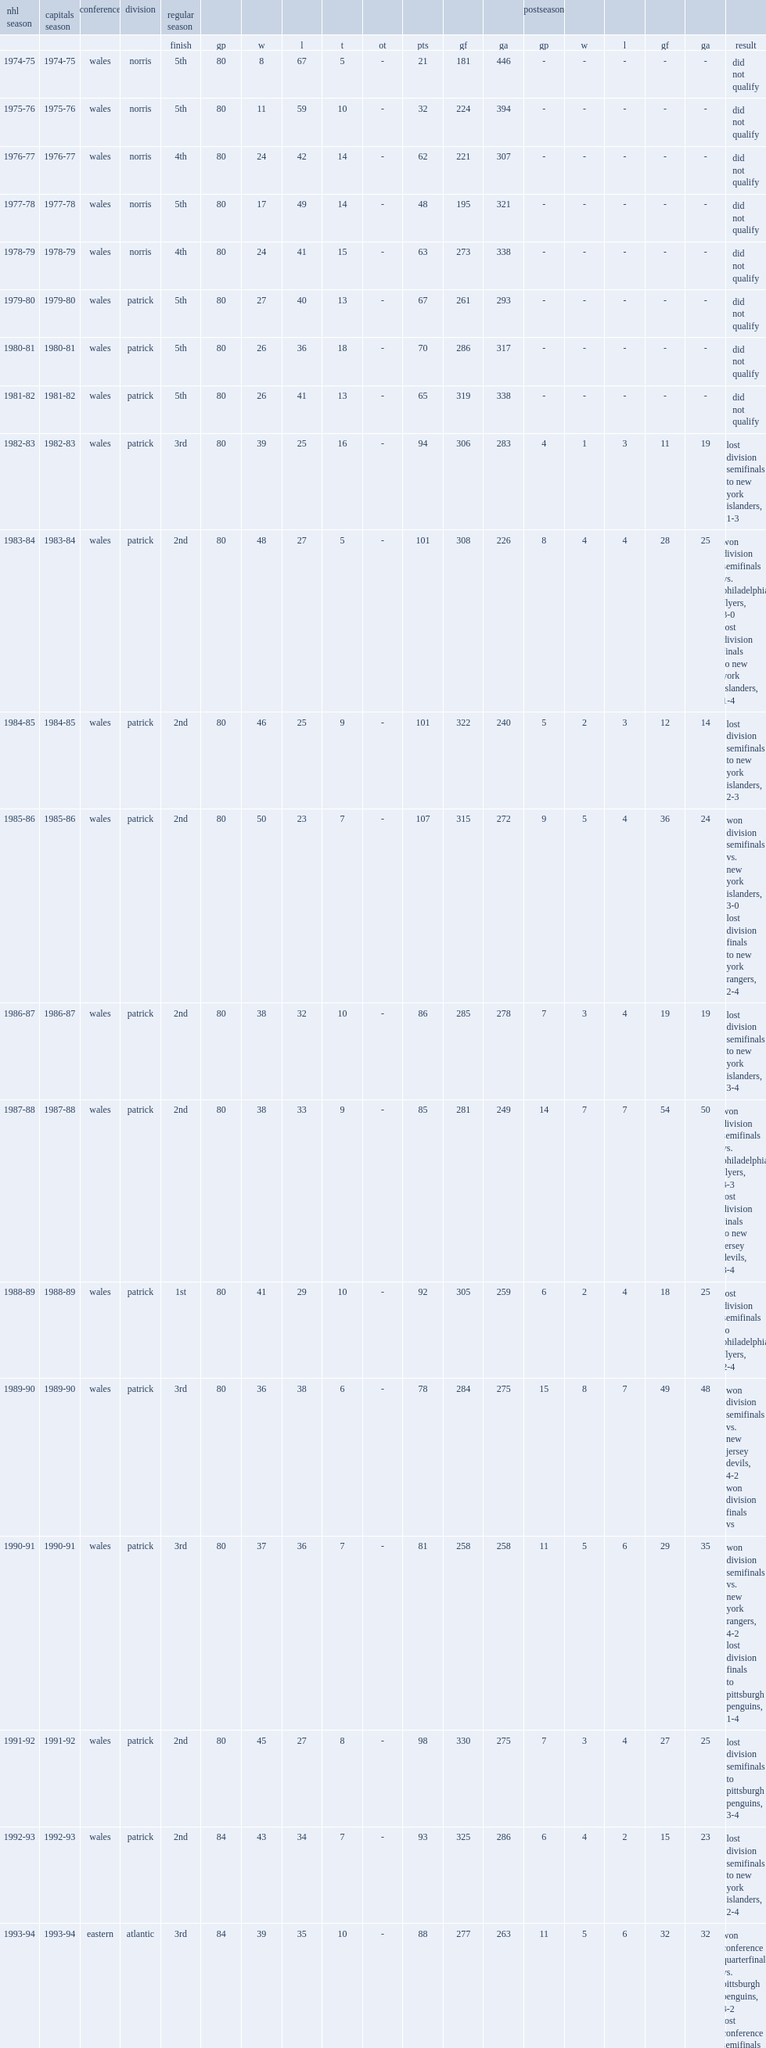When was the washington capitals season established? 1974-75. Which washington capitals season was the 45th season for the national hockey league? 2018-19. 